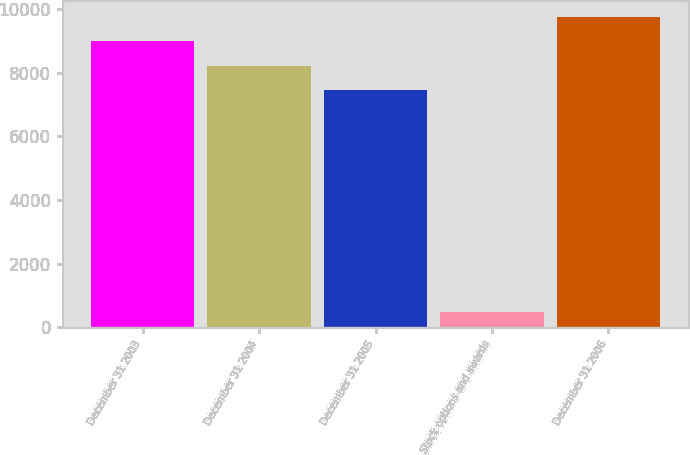Convert chart. <chart><loc_0><loc_0><loc_500><loc_500><bar_chart><fcel>December 31 2003<fcel>December 31 2004<fcel>December 31 2005<fcel>Stock options and awards<fcel>December 31 2006<nl><fcel>8994.6<fcel>8225.8<fcel>7457<fcel>490<fcel>9763.4<nl></chart> 